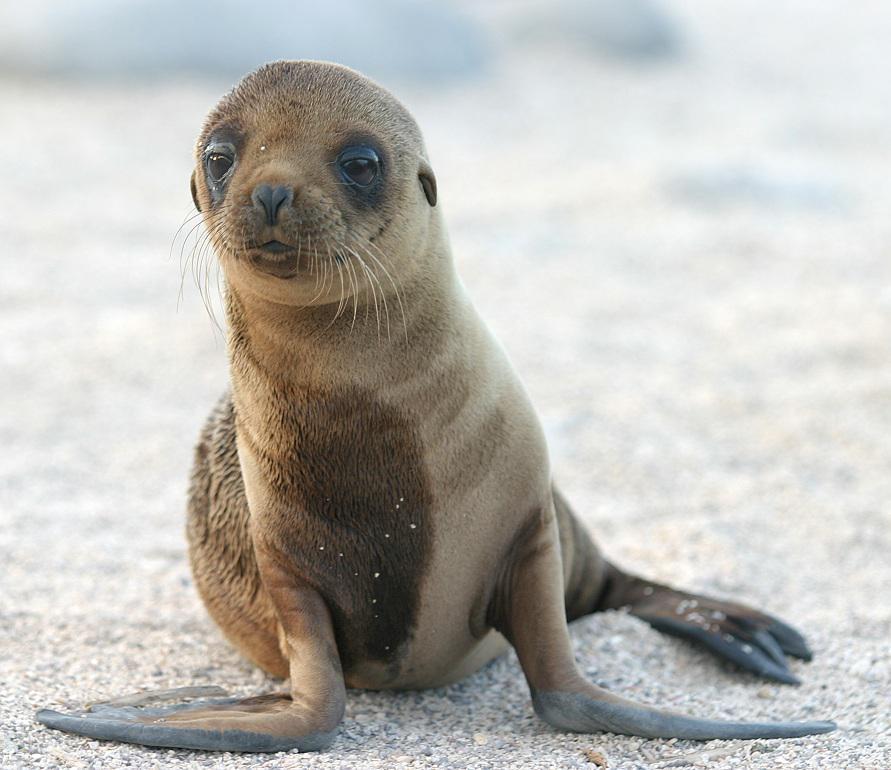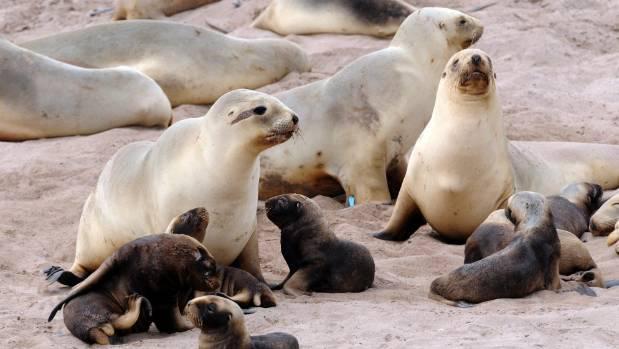The first image is the image on the left, the second image is the image on the right. Given the left and right images, does the statement "Right and left image contain the same number of seals." hold true? Answer yes or no. No. The first image is the image on the left, the second image is the image on the right. Examine the images to the left and right. Is the description "The photo on the right contains three or more animals." accurate? Answer yes or no. Yes. 